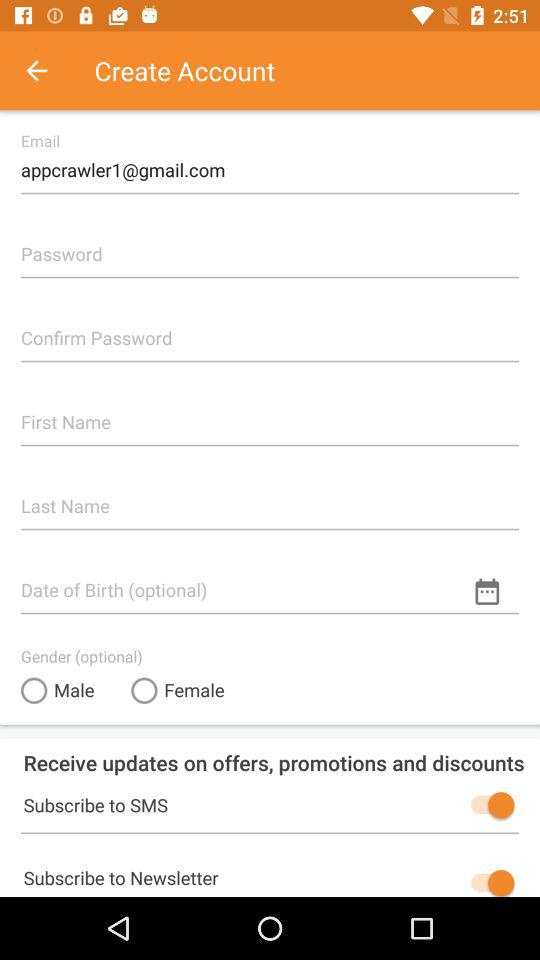What are the gender options? The gender options are male and female. 